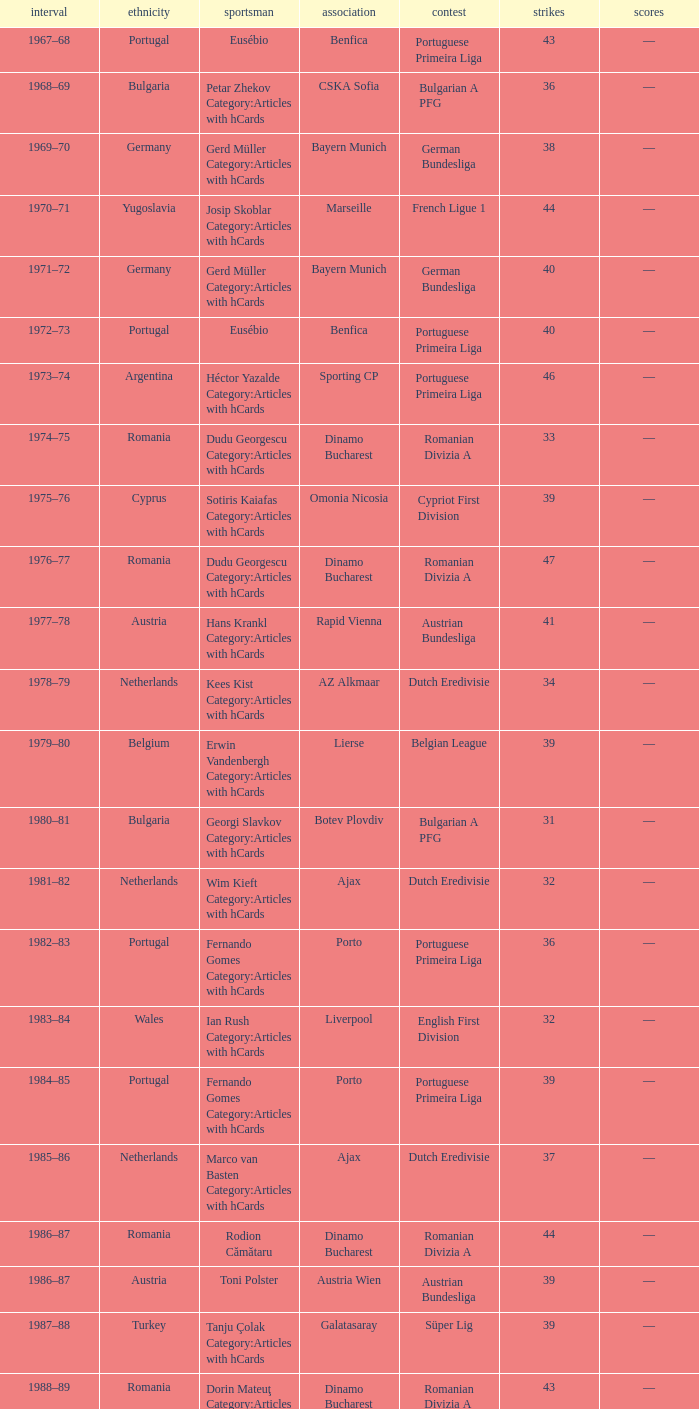Which player was in the Omonia Nicosia club? Sotiris Kaiafas Category:Articles with hCards. 